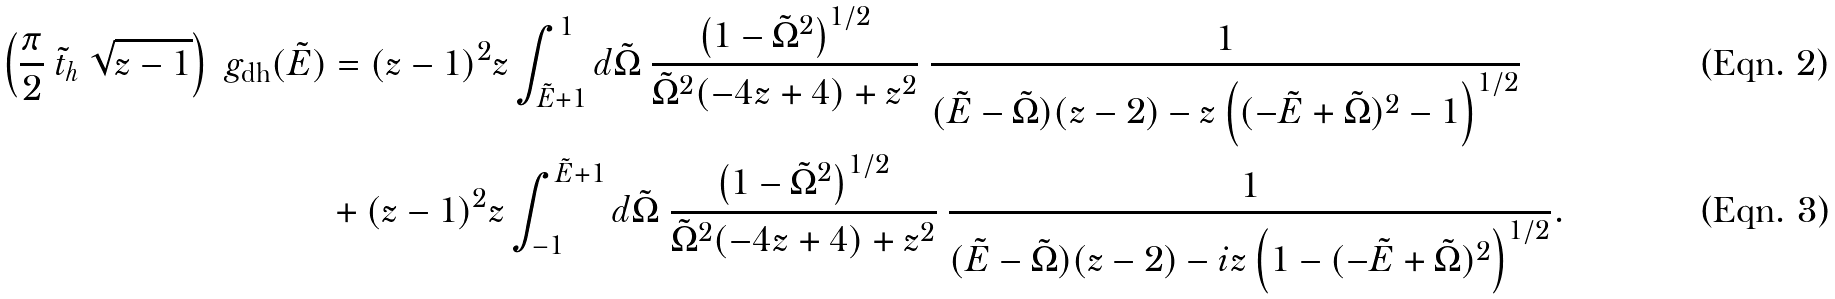Convert formula to latex. <formula><loc_0><loc_0><loc_500><loc_500>\left ( \frac { \pi } { 2 } \ \tilde { t } _ { h } \ \sqrt { z - 1 } \right ) \ g _ { \text {dh} } ( \tilde { E } ) & = ( z - 1 ) ^ { 2 } z \int _ { \tilde { E } + 1 } ^ { 1 } d \tilde { \Omega } \ \frac { \left ( 1 - \tilde { \Omega } ^ { 2 } \right ) ^ { 1 / 2 } } { \tilde { \Omega } ^ { 2 } ( - 4 z + 4 ) + z ^ { 2 } } \ \frac { 1 } { ( \tilde { E } - \tilde { \Omega } ) ( z - 2 ) - z \left ( ( - \tilde { E } + \tilde { \Omega } ) ^ { 2 } - 1 \right ) ^ { 1 / 2 } } \\ & + ( z - 1 ) ^ { 2 } z \int ^ { \tilde { E } + 1 } _ { - 1 } d \tilde { \Omega } \ \frac { \left ( 1 - \tilde { \Omega } ^ { 2 } \right ) ^ { 1 / 2 } } { \tilde { \Omega } ^ { 2 } ( - 4 z + 4 ) + z ^ { 2 } } \ \frac { 1 } { ( \tilde { E } - \tilde { \Omega } ) ( z - 2 ) - i z \left ( 1 - ( - \tilde { E } + \tilde { \Omega } ) ^ { 2 } \right ) ^ { 1 / 2 } } .</formula> 